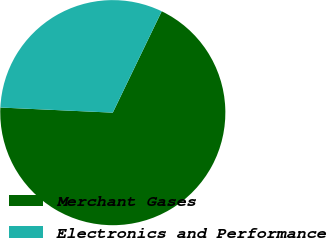Convert chart to OTSL. <chart><loc_0><loc_0><loc_500><loc_500><pie_chart><fcel>Merchant Gases<fcel>Electronics and Performance<nl><fcel>68.57%<fcel>31.43%<nl></chart> 